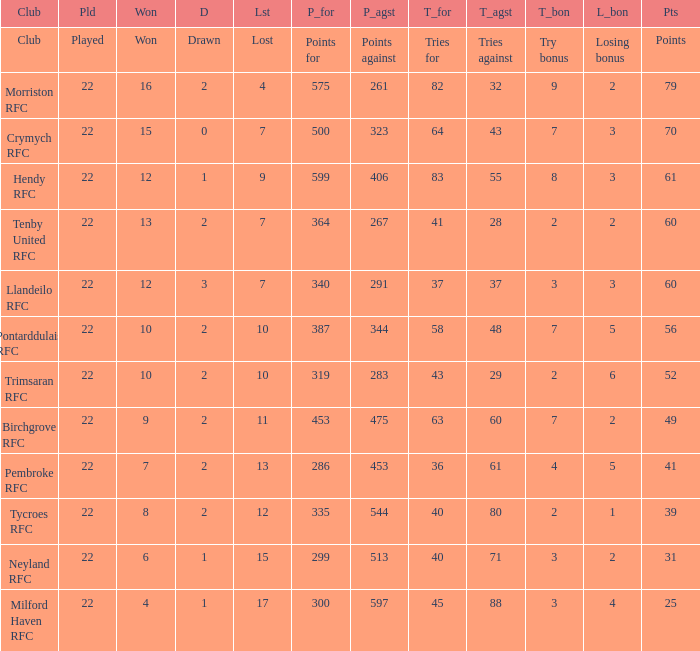What's the club with losing bonus being 1 Tycroes RFC. 